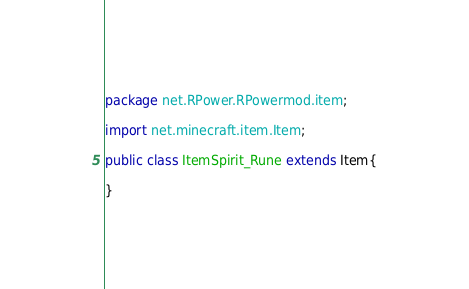Convert code to text. <code><loc_0><loc_0><loc_500><loc_500><_Java_>package net.RPower.RPowermod.item;

import net.minecraft.item.Item;

public class ItemSpirit_Rune extends Item{

}
</code> 